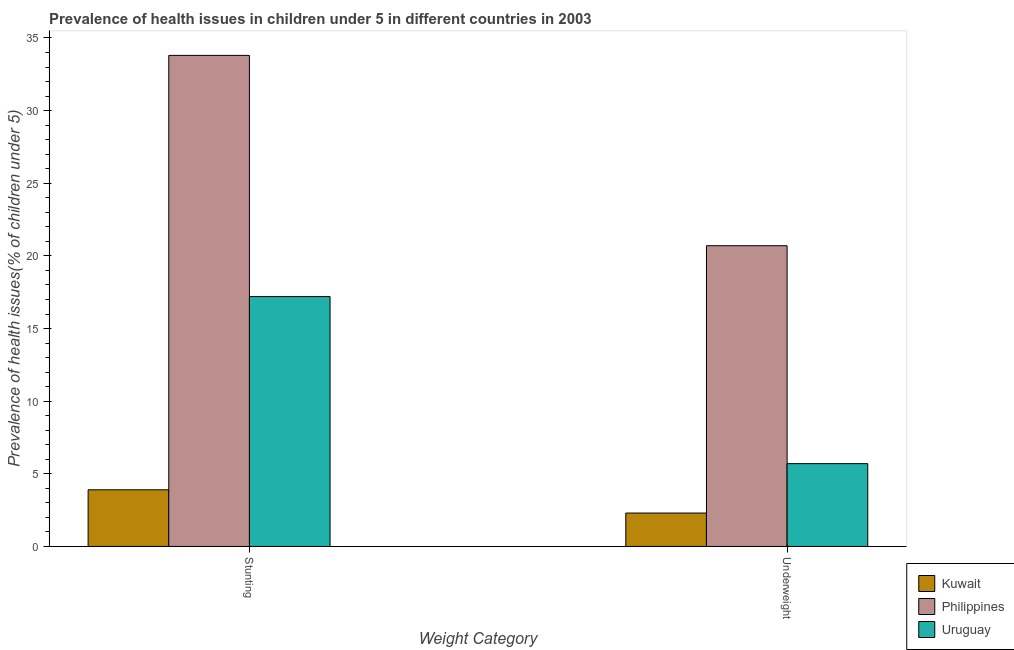How many different coloured bars are there?
Keep it short and to the point. 3. How many groups of bars are there?
Give a very brief answer. 2. How many bars are there on the 2nd tick from the right?
Your answer should be very brief. 3. What is the label of the 1st group of bars from the left?
Ensure brevity in your answer.  Stunting. What is the percentage of stunted children in Uruguay?
Your answer should be compact. 17.2. Across all countries, what is the maximum percentage of stunted children?
Provide a short and direct response. 33.8. Across all countries, what is the minimum percentage of underweight children?
Your answer should be compact. 2.3. In which country was the percentage of underweight children maximum?
Your answer should be compact. Philippines. In which country was the percentage of underweight children minimum?
Provide a short and direct response. Kuwait. What is the total percentage of underweight children in the graph?
Offer a terse response. 28.7. What is the difference between the percentage of stunted children in Uruguay and that in Philippines?
Provide a succinct answer. -16.6. What is the difference between the percentage of stunted children in Philippines and the percentage of underweight children in Kuwait?
Give a very brief answer. 31.5. What is the average percentage of underweight children per country?
Provide a succinct answer. 9.57. What is the difference between the percentage of underweight children and percentage of stunted children in Philippines?
Your answer should be very brief. -13.1. In how many countries, is the percentage of stunted children greater than 34 %?
Offer a terse response. 0. What is the ratio of the percentage of stunted children in Uruguay to that in Philippines?
Ensure brevity in your answer.  0.51. What does the 1st bar from the left in Stunting represents?
Offer a very short reply. Kuwait. What does the 2nd bar from the right in Stunting represents?
Your response must be concise. Philippines. Are all the bars in the graph horizontal?
Your response must be concise. No. What is the difference between two consecutive major ticks on the Y-axis?
Offer a terse response. 5. Where does the legend appear in the graph?
Ensure brevity in your answer.  Bottom right. How are the legend labels stacked?
Your answer should be compact. Vertical. What is the title of the graph?
Make the answer very short. Prevalence of health issues in children under 5 in different countries in 2003. Does "Other small states" appear as one of the legend labels in the graph?
Offer a terse response. No. What is the label or title of the X-axis?
Ensure brevity in your answer.  Weight Category. What is the label or title of the Y-axis?
Your answer should be compact. Prevalence of health issues(% of children under 5). What is the Prevalence of health issues(% of children under 5) in Kuwait in Stunting?
Ensure brevity in your answer.  3.9. What is the Prevalence of health issues(% of children under 5) in Philippines in Stunting?
Ensure brevity in your answer.  33.8. What is the Prevalence of health issues(% of children under 5) in Uruguay in Stunting?
Provide a short and direct response. 17.2. What is the Prevalence of health issues(% of children under 5) in Kuwait in Underweight?
Make the answer very short. 2.3. What is the Prevalence of health issues(% of children under 5) of Philippines in Underweight?
Provide a short and direct response. 20.7. What is the Prevalence of health issues(% of children under 5) in Uruguay in Underweight?
Your response must be concise. 5.7. Across all Weight Category, what is the maximum Prevalence of health issues(% of children under 5) in Kuwait?
Keep it short and to the point. 3.9. Across all Weight Category, what is the maximum Prevalence of health issues(% of children under 5) of Philippines?
Provide a succinct answer. 33.8. Across all Weight Category, what is the maximum Prevalence of health issues(% of children under 5) of Uruguay?
Offer a terse response. 17.2. Across all Weight Category, what is the minimum Prevalence of health issues(% of children under 5) in Kuwait?
Your response must be concise. 2.3. Across all Weight Category, what is the minimum Prevalence of health issues(% of children under 5) in Philippines?
Offer a terse response. 20.7. Across all Weight Category, what is the minimum Prevalence of health issues(% of children under 5) in Uruguay?
Provide a succinct answer. 5.7. What is the total Prevalence of health issues(% of children under 5) in Philippines in the graph?
Ensure brevity in your answer.  54.5. What is the total Prevalence of health issues(% of children under 5) of Uruguay in the graph?
Provide a short and direct response. 22.9. What is the difference between the Prevalence of health issues(% of children under 5) in Kuwait in Stunting and the Prevalence of health issues(% of children under 5) in Philippines in Underweight?
Your answer should be very brief. -16.8. What is the difference between the Prevalence of health issues(% of children under 5) of Kuwait in Stunting and the Prevalence of health issues(% of children under 5) of Uruguay in Underweight?
Offer a very short reply. -1.8. What is the difference between the Prevalence of health issues(% of children under 5) of Philippines in Stunting and the Prevalence of health issues(% of children under 5) of Uruguay in Underweight?
Your answer should be compact. 28.1. What is the average Prevalence of health issues(% of children under 5) of Kuwait per Weight Category?
Keep it short and to the point. 3.1. What is the average Prevalence of health issues(% of children under 5) of Philippines per Weight Category?
Provide a short and direct response. 27.25. What is the average Prevalence of health issues(% of children under 5) in Uruguay per Weight Category?
Make the answer very short. 11.45. What is the difference between the Prevalence of health issues(% of children under 5) of Kuwait and Prevalence of health issues(% of children under 5) of Philippines in Stunting?
Provide a succinct answer. -29.9. What is the difference between the Prevalence of health issues(% of children under 5) of Philippines and Prevalence of health issues(% of children under 5) of Uruguay in Stunting?
Give a very brief answer. 16.6. What is the difference between the Prevalence of health issues(% of children under 5) in Kuwait and Prevalence of health issues(% of children under 5) in Philippines in Underweight?
Your answer should be compact. -18.4. What is the difference between the Prevalence of health issues(% of children under 5) in Philippines and Prevalence of health issues(% of children under 5) in Uruguay in Underweight?
Your response must be concise. 15. What is the ratio of the Prevalence of health issues(% of children under 5) in Kuwait in Stunting to that in Underweight?
Offer a very short reply. 1.7. What is the ratio of the Prevalence of health issues(% of children under 5) of Philippines in Stunting to that in Underweight?
Your answer should be very brief. 1.63. What is the ratio of the Prevalence of health issues(% of children under 5) of Uruguay in Stunting to that in Underweight?
Offer a very short reply. 3.02. What is the difference between the highest and the second highest Prevalence of health issues(% of children under 5) in Philippines?
Keep it short and to the point. 13.1. What is the difference between the highest and the lowest Prevalence of health issues(% of children under 5) of Kuwait?
Ensure brevity in your answer.  1.6. 